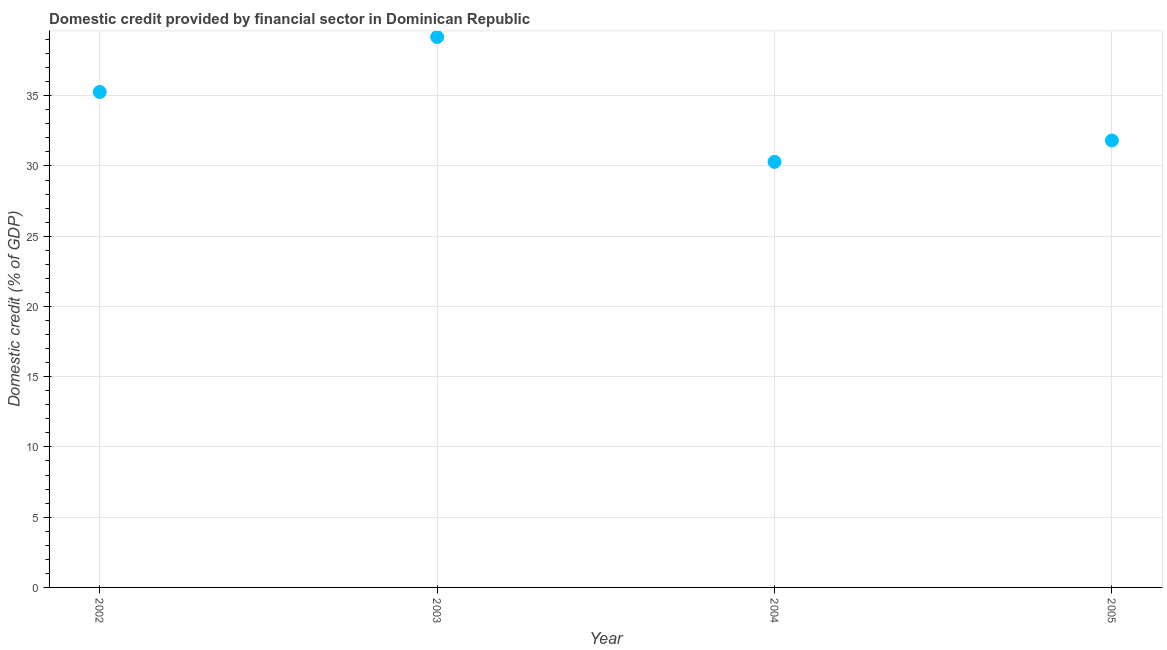What is the domestic credit provided by financial sector in 2004?
Give a very brief answer. 30.29. Across all years, what is the maximum domestic credit provided by financial sector?
Give a very brief answer. 39.18. Across all years, what is the minimum domestic credit provided by financial sector?
Offer a very short reply. 30.29. What is the sum of the domestic credit provided by financial sector?
Keep it short and to the point. 136.55. What is the difference between the domestic credit provided by financial sector in 2002 and 2003?
Provide a succinct answer. -3.91. What is the average domestic credit provided by financial sector per year?
Make the answer very short. 34.14. What is the median domestic credit provided by financial sector?
Offer a terse response. 33.54. In how many years, is the domestic credit provided by financial sector greater than 37 %?
Ensure brevity in your answer.  1. What is the ratio of the domestic credit provided by financial sector in 2003 to that in 2004?
Make the answer very short. 1.29. What is the difference between the highest and the second highest domestic credit provided by financial sector?
Offer a terse response. 3.91. What is the difference between the highest and the lowest domestic credit provided by financial sector?
Your answer should be very brief. 8.89. In how many years, is the domestic credit provided by financial sector greater than the average domestic credit provided by financial sector taken over all years?
Your answer should be very brief. 2. How many dotlines are there?
Provide a succinct answer. 1. What is the difference between two consecutive major ticks on the Y-axis?
Provide a succinct answer. 5. Does the graph contain any zero values?
Your answer should be compact. No. Does the graph contain grids?
Keep it short and to the point. Yes. What is the title of the graph?
Ensure brevity in your answer.  Domestic credit provided by financial sector in Dominican Republic. What is the label or title of the X-axis?
Offer a terse response. Year. What is the label or title of the Y-axis?
Your response must be concise. Domestic credit (% of GDP). What is the Domestic credit (% of GDP) in 2002?
Make the answer very short. 35.27. What is the Domestic credit (% of GDP) in 2003?
Offer a very short reply. 39.18. What is the Domestic credit (% of GDP) in 2004?
Ensure brevity in your answer.  30.29. What is the Domestic credit (% of GDP) in 2005?
Your answer should be very brief. 31.81. What is the difference between the Domestic credit (% of GDP) in 2002 and 2003?
Ensure brevity in your answer.  -3.91. What is the difference between the Domestic credit (% of GDP) in 2002 and 2004?
Keep it short and to the point. 4.98. What is the difference between the Domestic credit (% of GDP) in 2002 and 2005?
Provide a succinct answer. 3.45. What is the difference between the Domestic credit (% of GDP) in 2003 and 2004?
Keep it short and to the point. 8.89. What is the difference between the Domestic credit (% of GDP) in 2003 and 2005?
Ensure brevity in your answer.  7.36. What is the difference between the Domestic credit (% of GDP) in 2004 and 2005?
Offer a terse response. -1.52. What is the ratio of the Domestic credit (% of GDP) in 2002 to that in 2003?
Provide a short and direct response. 0.9. What is the ratio of the Domestic credit (% of GDP) in 2002 to that in 2004?
Your answer should be very brief. 1.16. What is the ratio of the Domestic credit (% of GDP) in 2002 to that in 2005?
Make the answer very short. 1.11. What is the ratio of the Domestic credit (% of GDP) in 2003 to that in 2004?
Provide a succinct answer. 1.29. What is the ratio of the Domestic credit (% of GDP) in 2003 to that in 2005?
Your answer should be compact. 1.23. What is the ratio of the Domestic credit (% of GDP) in 2004 to that in 2005?
Make the answer very short. 0.95. 